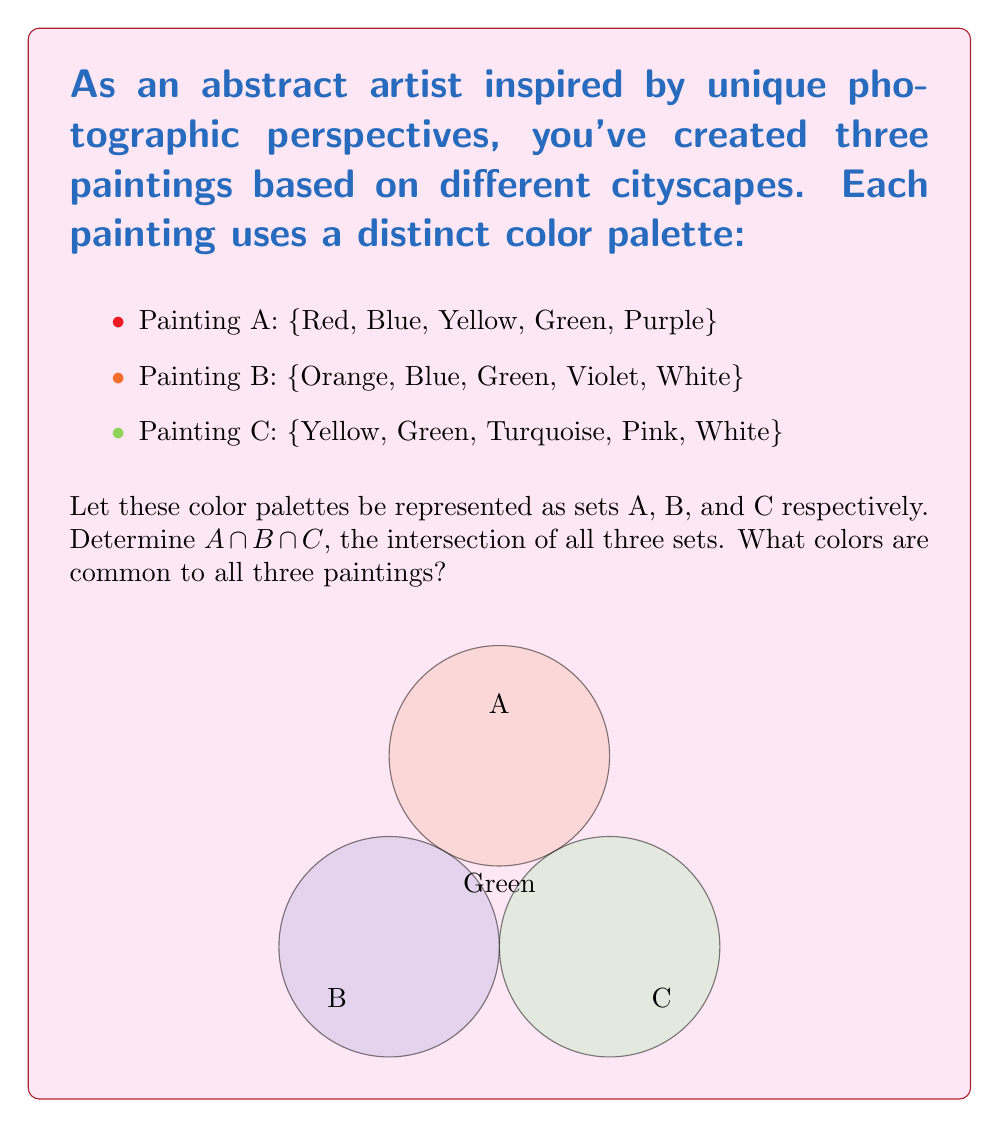Can you solve this math problem? To find the intersection of sets A, B, and C, we need to identify the colors that appear in all three sets. Let's approach this step-by-step:

1) First, let's write out our sets:
   A = {Red, Blue, Yellow, Green, Purple}
   B = {Orange, Blue, Green, Violet, White}
   C = {Yellow, Green, Turquoise, Pink, White}

2) To find $A \cap B \cap C$, we need to identify colors that are present in all three sets.

3) Let's start by comparing A and B:
   A ∩ B = {Blue, Green}

4) Now, let's compare this result with set C:
   (A ∩ B) ∩ C = {Green}

5) We can verify this result by checking if Green is indeed present in all three original sets, which it is.

Therefore, the intersection of all three sets, $A \cap B \cap C$, contains only the color Green.

This result can be interpreted artistically as Green being the unifying color across all three of your cityscape-inspired abstract paintings, perhaps representing a common element like nature or life amidst urban environments.
Answer: $A \cap B \cap C = \{Green\}$ 